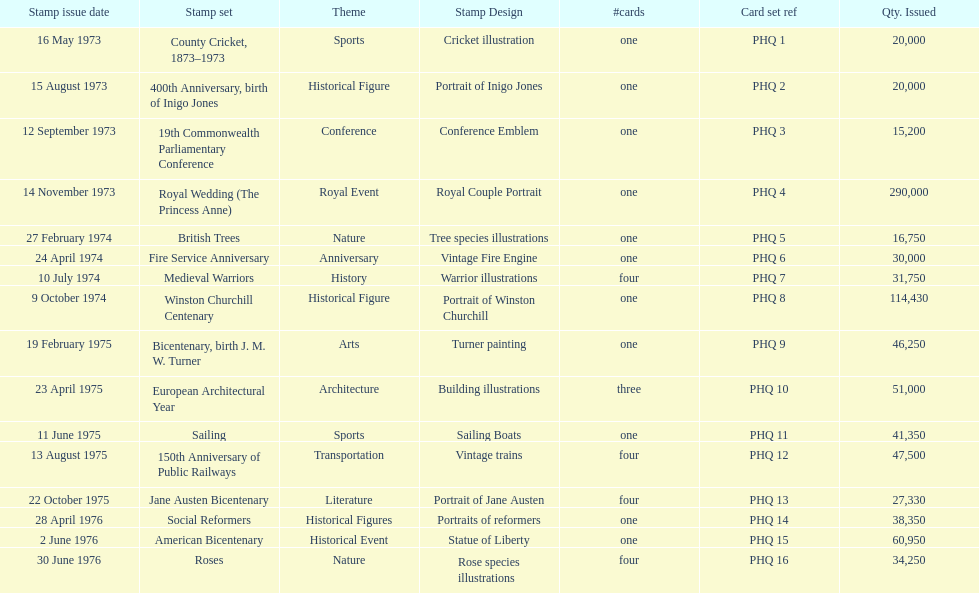Which stamp kit consisted of only three cards in the compilation? European Architectural Year. 